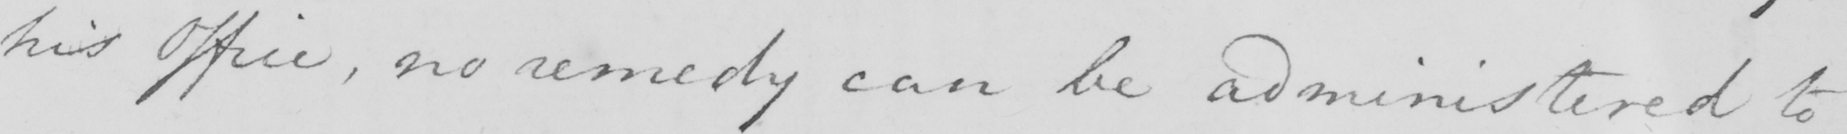Please transcribe the handwritten text in this image. his Office , no remedy can be administered to 